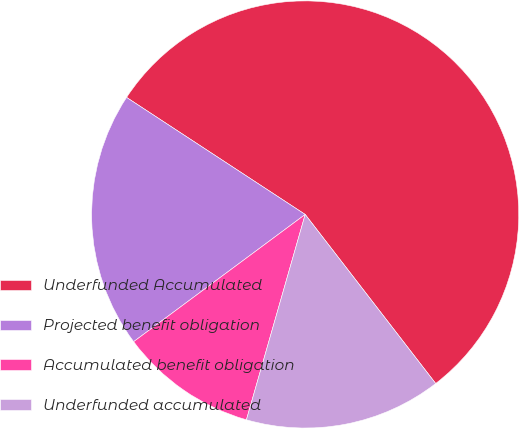<chart> <loc_0><loc_0><loc_500><loc_500><pie_chart><fcel>Underfunded Accumulated<fcel>Projected benefit obligation<fcel>Accumulated benefit obligation<fcel>Underfunded accumulated<nl><fcel>55.31%<fcel>19.39%<fcel>10.41%<fcel>14.9%<nl></chart> 